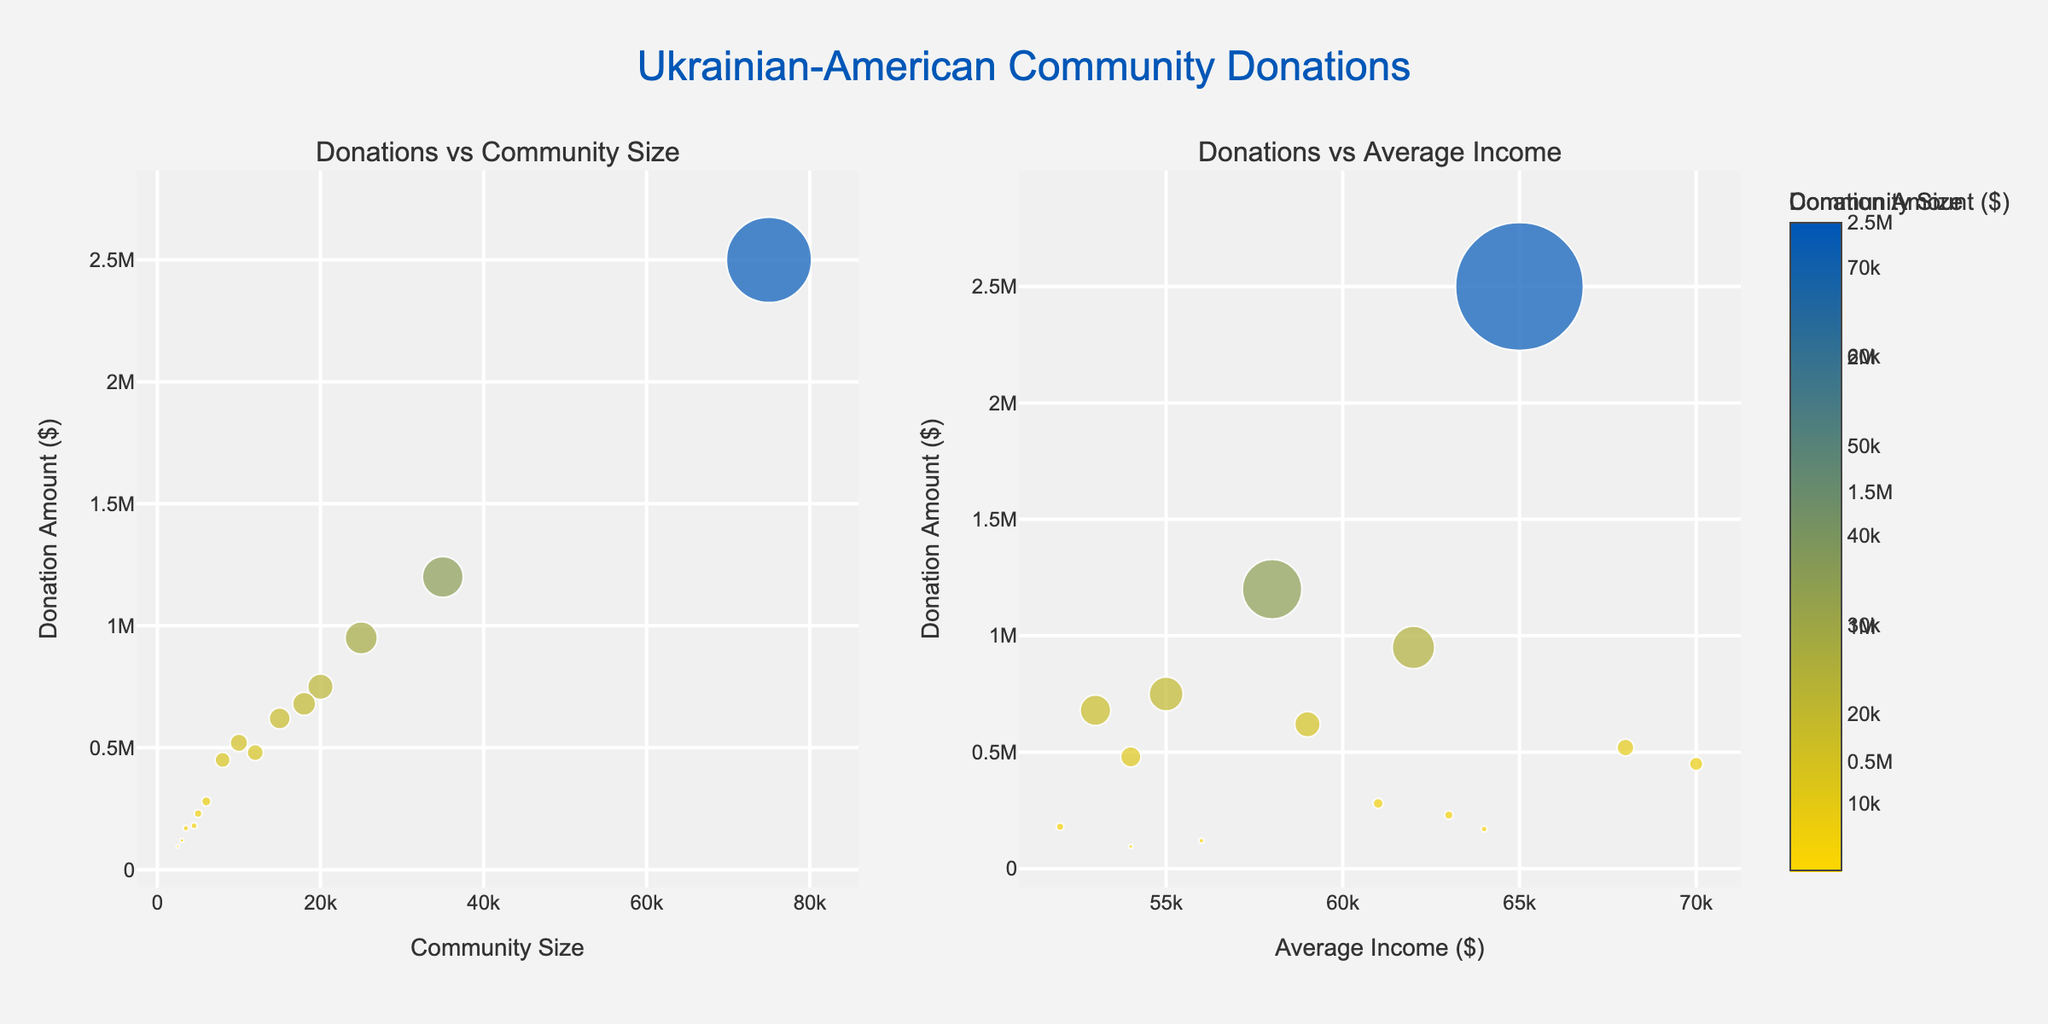How many cities are represented in the "Donations vs Community Size" scatter plot? There are distinct data points on the scatter plot, each representing a city. Count the markers to find that there are 15 cities.
Answer: 15 Which city has the highest donation amount, and what is that amount? Look at the scatter plot and find the data point at the highest y-axis value. Hover over the point to see that New York has the highest donation amount of $2,500,000.
Answer: New York, $2,500,000 Do larger communities tend to donate more in absolute terms? Observe the trend in the "Donations vs Community Size" plot. Larger communities like New York and Chicago have higher donation amounts, indicating a positive correlation between community size and donation amount.
Answer: Yes How does the donation amount for Portland compare to that for Buffalo? Locate the data points for Portland and Buffalo in the "Donations vs Community Size" plot. Portland's donation amount is $170,000, and Buffalo's is $180,000. Compare the values to see that Buffalo has a slightly higher donation amount.
Answer: Buffalo has a higher donation amount What is the relationship between community size and donation amount based on the scatter plot? The "Donations vs Community Size" plot shows that larger communities generally have higher donation amounts, suggesting a positive correlation.
Answer: Positive correlation Which city shows the highest average income, and what is its donation amount? In the "Donations vs Average Income" plot, locate the marker with the highest x-axis value. Hovering over the marker shows that Boston has the highest average income of $70,000 and a donation amount of $450,000.
Answer: Boston, $450,000 Is there a city where a relatively small community size is associated with a relatively high donation amount? Observe the data points in the "Donations vs Community Size" scatter plot to find small community sizes with high donation amounts. Hartford, with a community size of 5,000 and a donation amount of $230,000, fits this description.
Answer: Yes, Hartford How does Seattle's donation amount relative to its community size and average income compare to other cities? In both scatter plots, compare Seattle's data point to others by its position and hovering over the details. Seattle has a community size of 10,000, average income of $68,000, and a donation amount of $520,000. This relative position suggests Seattle performs well in donations compared to its size.
Answer: Seattle performs well Which city has the smallest community size, and what is its donation amount? Find the smallest x-axis value in the "Donations vs Community Size" scatter plot. Syracuse, with a community size of 2,500, has a donation amount of $95,000.
Answer: Syracuse, $95,000 